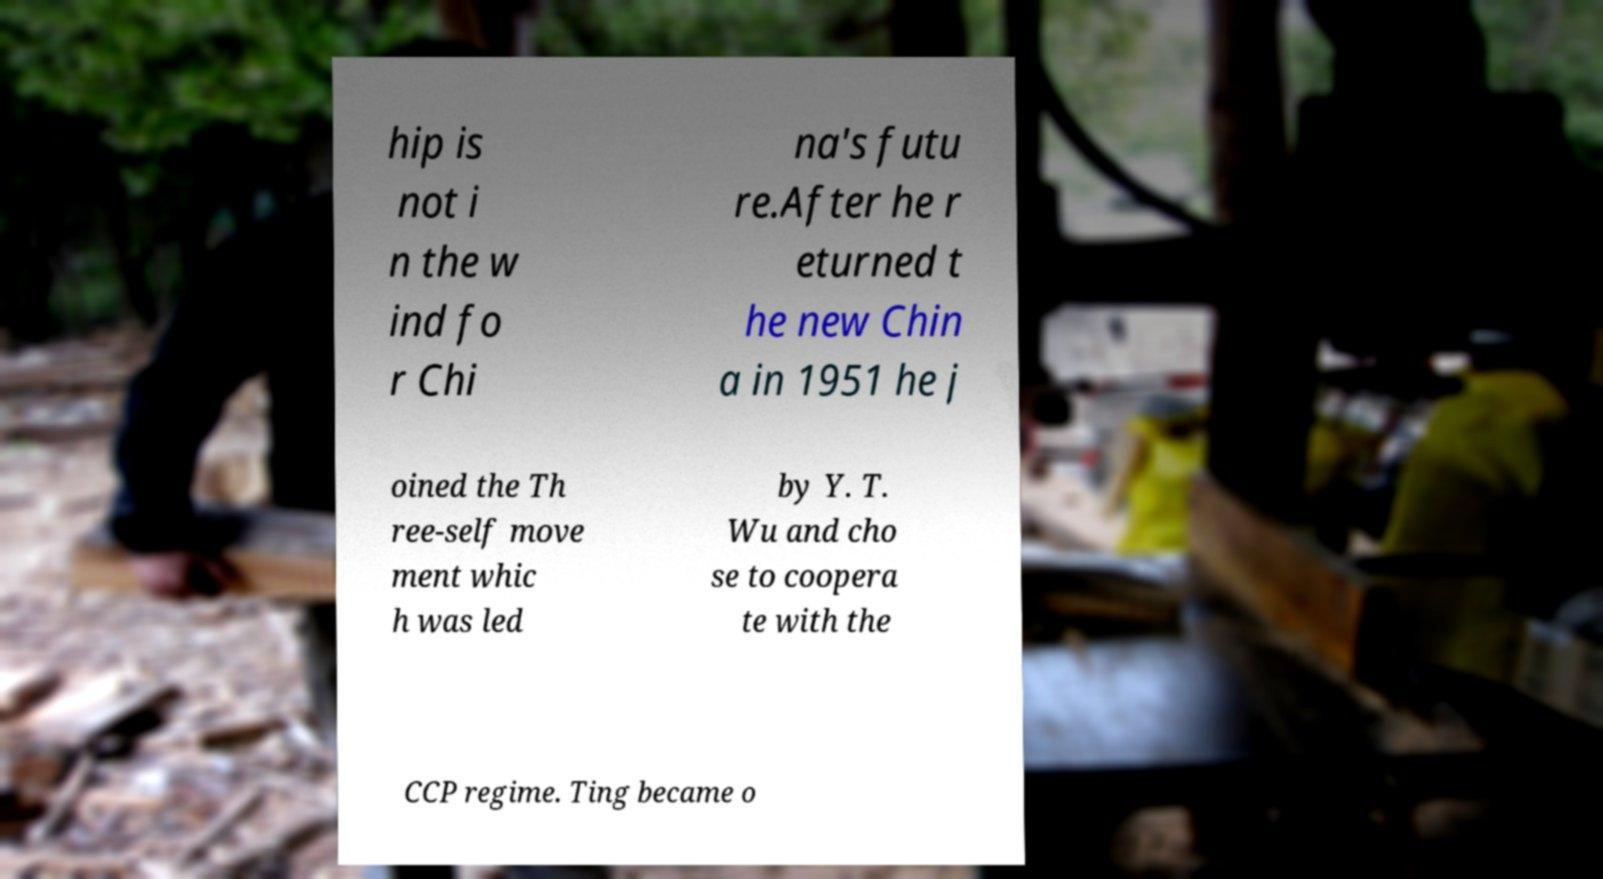What messages or text are displayed in this image? I need them in a readable, typed format. hip is not i n the w ind fo r Chi na's futu re.After he r eturned t he new Chin a in 1951 he j oined the Th ree-self move ment whic h was led by Y. T. Wu and cho se to coopera te with the CCP regime. Ting became o 